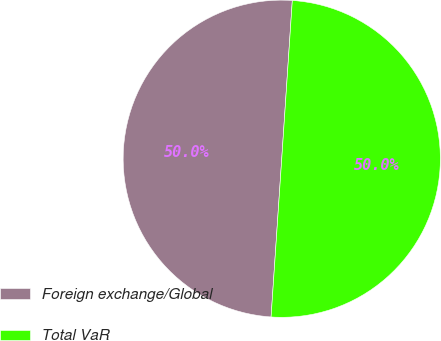Convert chart. <chart><loc_0><loc_0><loc_500><loc_500><pie_chart><fcel>Foreign exchange/Global<fcel>Total VaR<nl><fcel>49.99%<fcel>50.01%<nl></chart> 